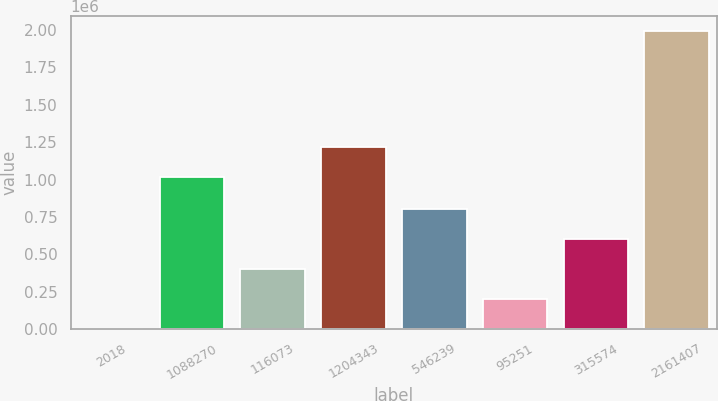Convert chart. <chart><loc_0><loc_0><loc_500><loc_500><bar_chart><fcel>2018<fcel>1088270<fcel>116073<fcel>1204343<fcel>546239<fcel>95251<fcel>315574<fcel>2161407<nl><fcel>2016<fcel>1.01905e+06<fcel>400620<fcel>1.21836e+06<fcel>799223<fcel>201318<fcel>599921<fcel>1.99503e+06<nl></chart> 